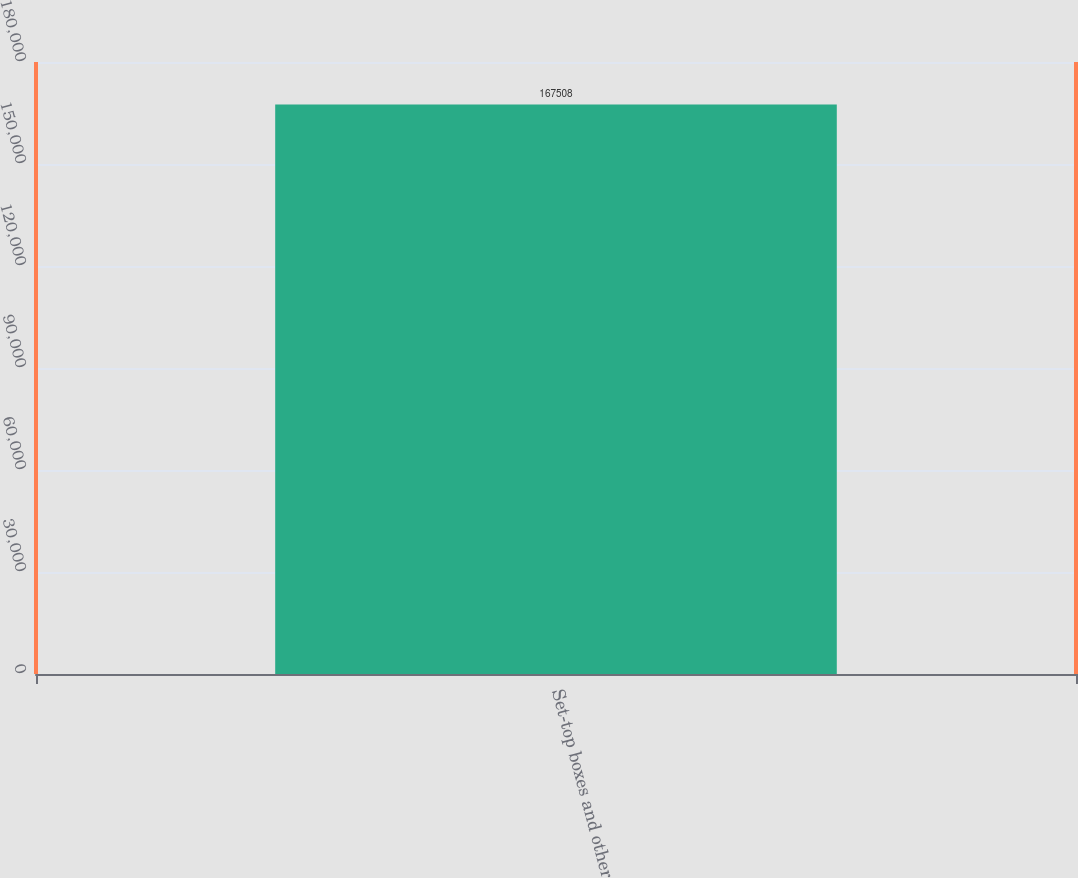Convert chart to OTSL. <chart><loc_0><loc_0><loc_500><loc_500><bar_chart><fcel>Set-top boxes and other<nl><fcel>167508<nl></chart> 